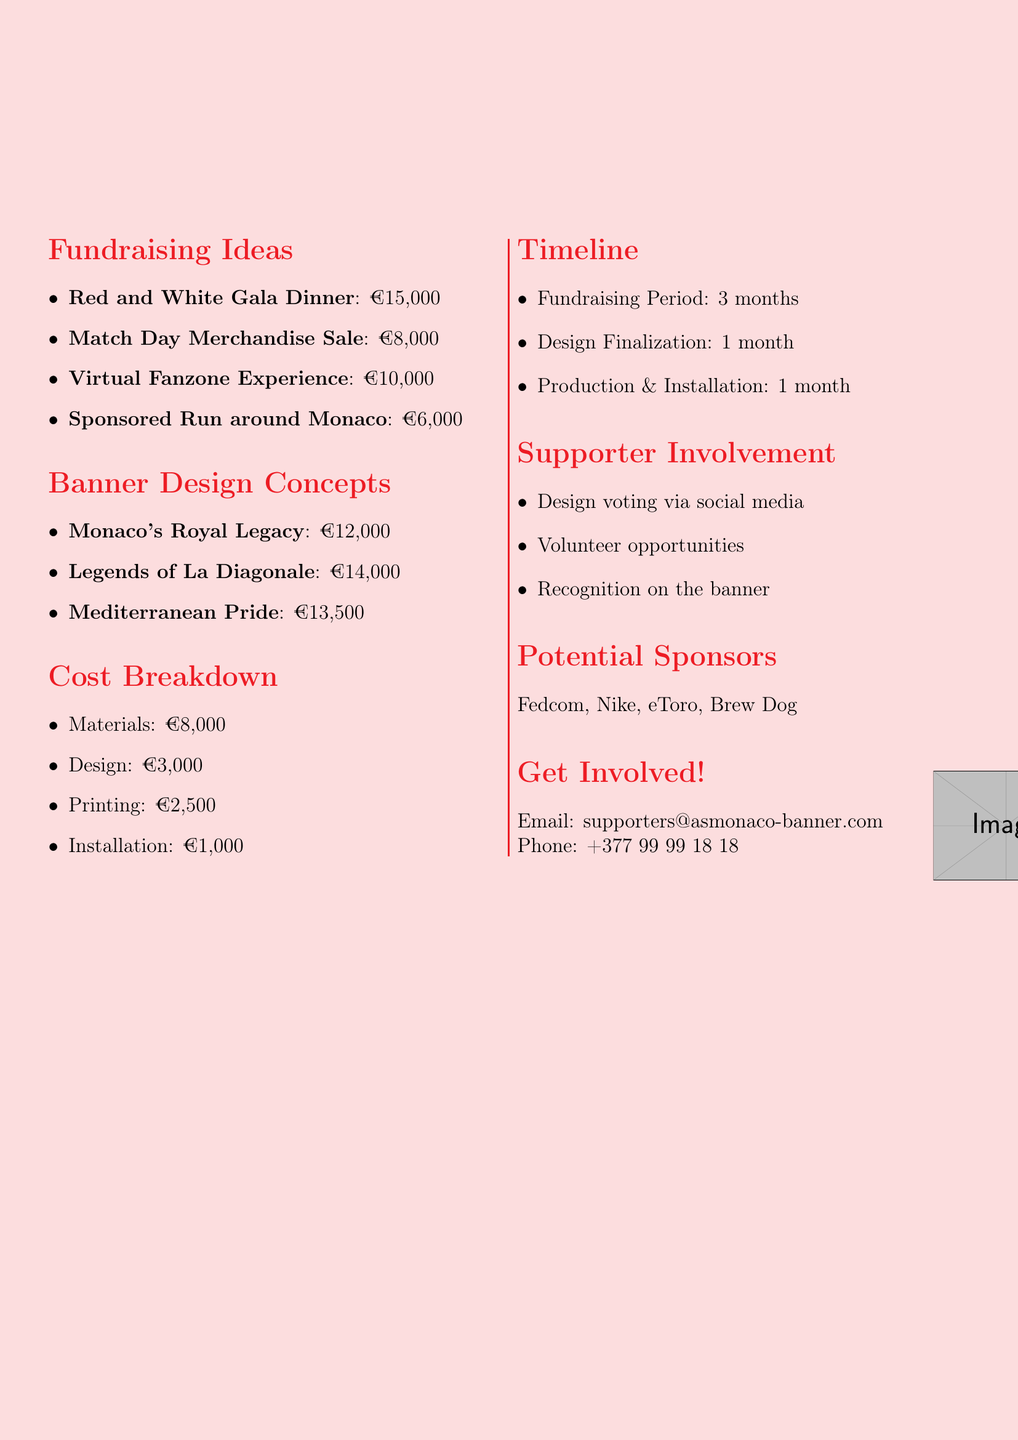What is the title of the memo? The title of the memo is presented at the beginning of the document, reflecting the subject matter.
Answer: Fundraising Initiative for New AS Monaco FC Banner at Stade Louis II What is the estimated revenue from the Red and White Gala Dinner? The document specifies the estimated revenue for the gala dinner within the fundraising ideas section.
Answer: €15,000 How long is the fundraising period? This information is found in the timeline section of the memo, outlining the duration for fundraising activities.
Answer: 3 months What is the estimated cost of the "Legends of La Diagonale" banner design? The estimated cost is detailed in the banner design concepts section for each proposed design.
Answer: €14,000 What is the total estimated revenue from all fundraising ideas? This is computed by summing the estimated revenues provided for each fundraising idea listed in the document.
Answer: €39,000 How many months are allocated for the design finalization? The timeline section outlines the specific duration set for finalizing the design.
Answer: 1 month What are the names of potential sponsors mentioned in the document? The document lists potential sponsors in a specific section with their names explicitly stated.
Answer: Fedcom, Nike, eToro, Brew Dog What opportunity is provided for supporter involvement regarding design? The memo explains how supporters can engage with the final design selection process.
Answer: Design voting via social media What is included in the recognition idea for supporters? This information describes how supporters' contributions will be acknowledged on the banner.
Answer: Names of contributing supporters in a special section of the banner 